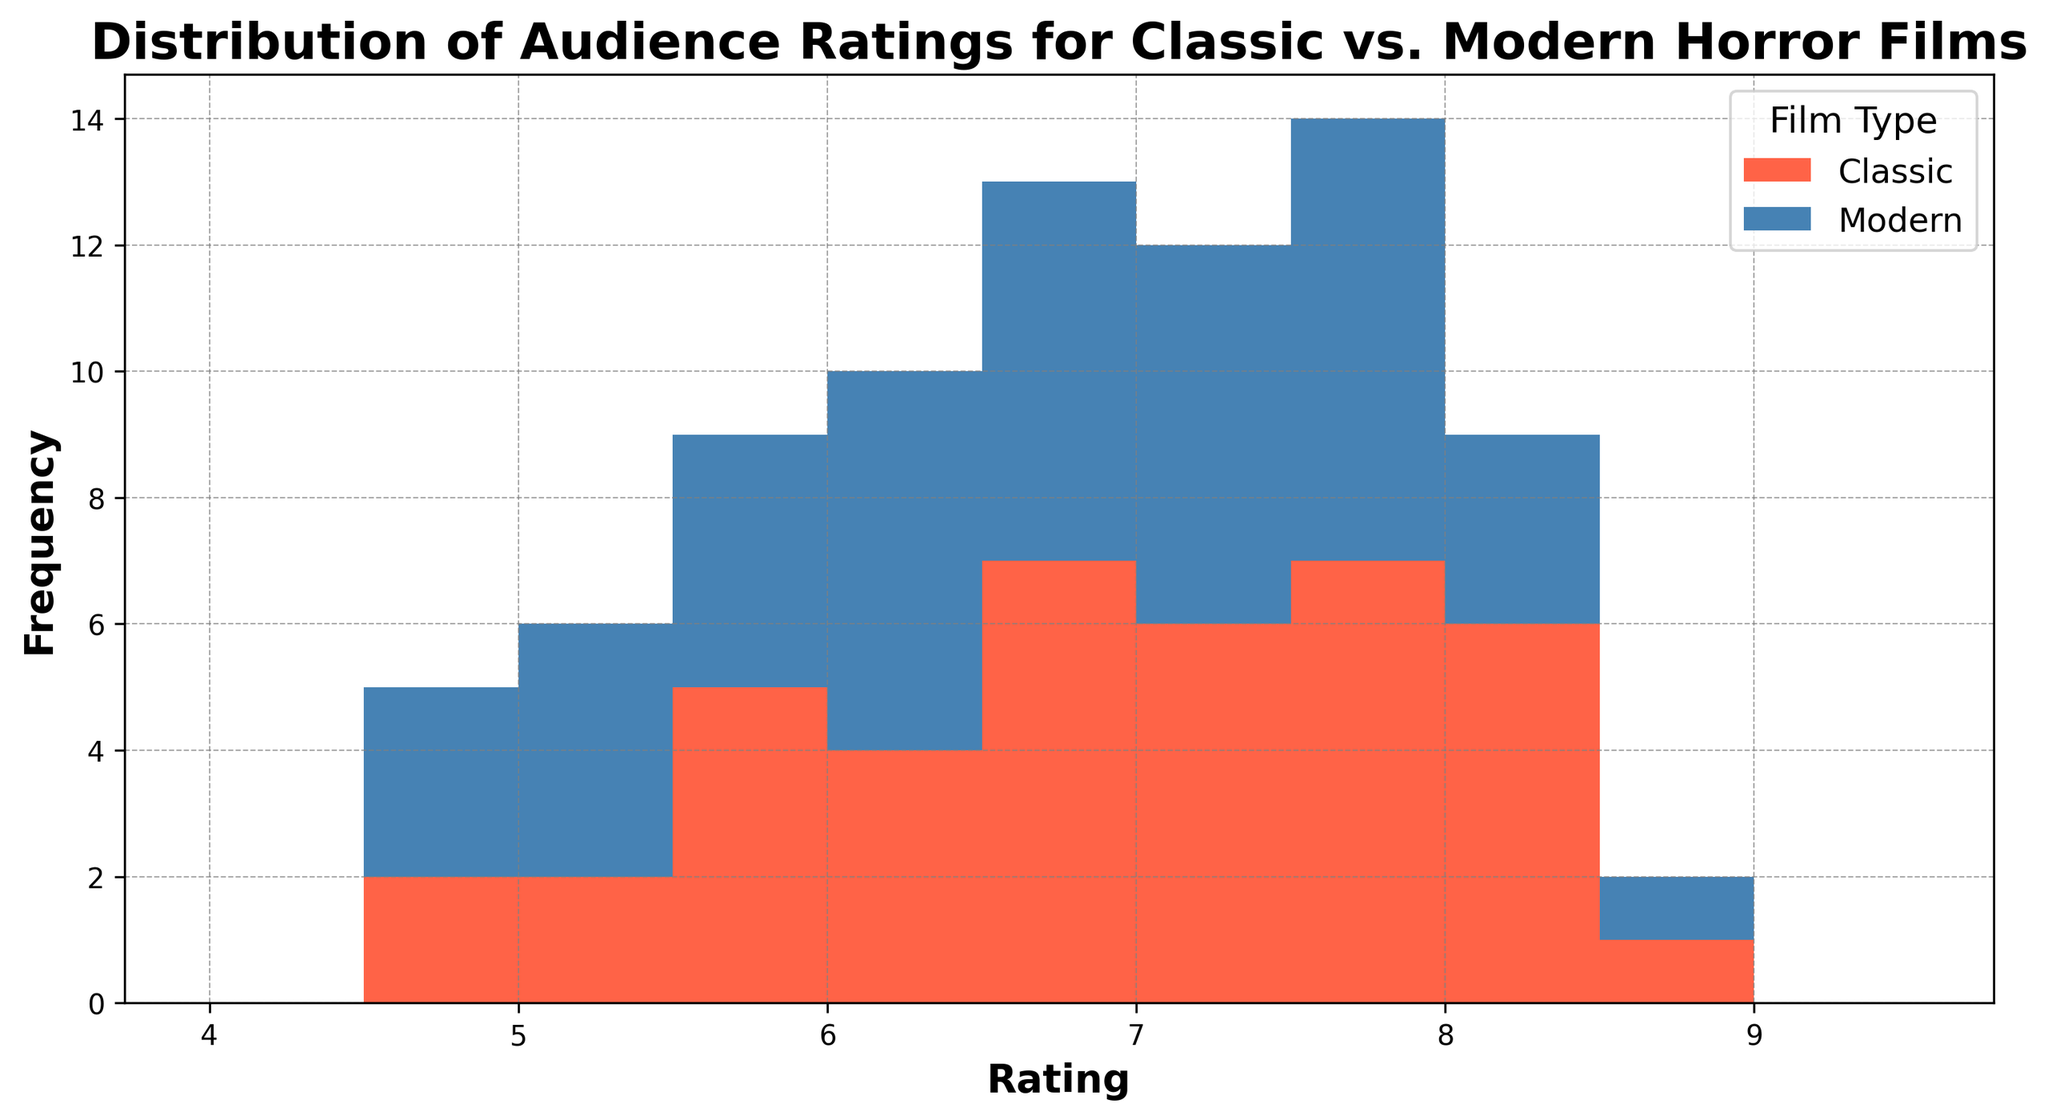What is the main color representing Classic horror films in the histogram? The color representing Classic horror films is red. It is mentioned that the colors used in the plot are '#FF6347', which is a shade of red, for Classic films.
Answer: Red Which film type generally has higher ratings based on the histogram's visual information? Observing the histogram, Classic horror films generally have higher frequencies in the higher rating bins compared to Modern horror films. Higher frequency bars for Classic films are more evident in the 7.5-8.5 rating range.
Answer: Classic How does the frequency of ratings between 7.0 and 8.0 compare for Classic and Modern horror films? To compare, observe the bars between the 7.0-7.5 and 7.5-8.0 intervals. Classic horror films have higher bars in these intervals compared to Modern horror films, indicating Classic films have more ratings within this range.
Answer: Classic has higher frequency What is the difference in frequency between the highest rating bin (8.5) for Classic and Modern films? In the 8.5 rating bin, count the height of the bars for both Classic and Modern films. Classic films have a visible tall bar, while the Modern film's bar is shorter or nearly absent. The difference is the Classic bar height minus the Modern bar height.
Answer: 1 (or more depending on exact bar heights) In which rating bin does the Modern horror film reach its highest frequency? Observe the histogram and identify the highest bar representing Modern horror films. The highest bar for Modern horror films is in the 7.5-8.0 rating bin.
Answer: 7.5-8.0 In which rating bins do Classic horror films have no ratings? Identify intervals where there are no red bars. Observing from 4 to 10, the bins with no red bars are in the 4.0-4.5 and 9.0-9.5 intervals.
Answer: 4.0-4.5, 9.0-9.5 What is the total number of rating intervals where Modern horror films have higher frequencies than Classic films? For each bin, compare the heights of the bars for Classic and Modern horror films. Count the bins where the Modern film bar is taller. It appears that Modern films surpass Classic ones in 4.5-5.0, 7.5-8.0, and possibly one other interval within the histogram.
Answer: 3 What is the average rating for Classic horror movies? First sum the ratings for Classic horror films. The sum of Classic ratings is (7.8 + 6.2 + ... + 7.6 + 6.9). Then, divide by the number of Classic ratings (40 in total). This simplifies to (approximately) 273/40 = 6.825.
Answer: 6.825 What is the range of ratings for Modern horror films depicted in this histogram? Modern horror films have ratings ranging from the lowest visible bin (4.5) to the highest filled bin (8.5).
Answer: 4.5 - 8.5 Which film type shows more variability in ratings, Classic or Modern horror films? Variability can be estimated by observing the spread of bars. Classic horror films have bars across a wide range (from 4.0 to 9.0), while Modern films also have a wide spread but seem concentrated between 4.5 and 8.5. This suggests that Classic horror films might show slightly more variability in ratings.
Answer: Classic 